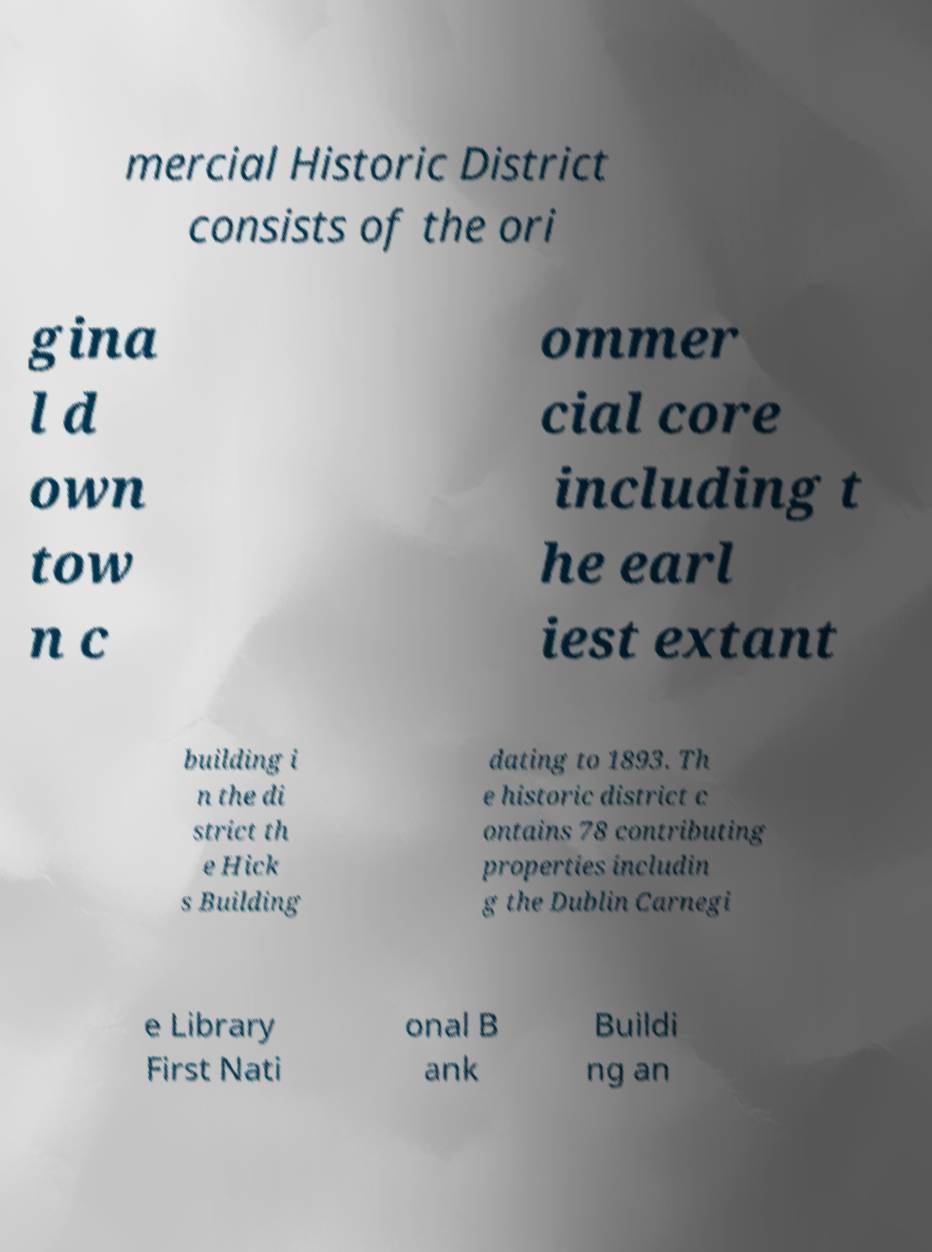Can you accurately transcribe the text from the provided image for me? mercial Historic District consists of the ori gina l d own tow n c ommer cial core including t he earl iest extant building i n the di strict th e Hick s Building dating to 1893. Th e historic district c ontains 78 contributing properties includin g the Dublin Carnegi e Library First Nati onal B ank Buildi ng an 